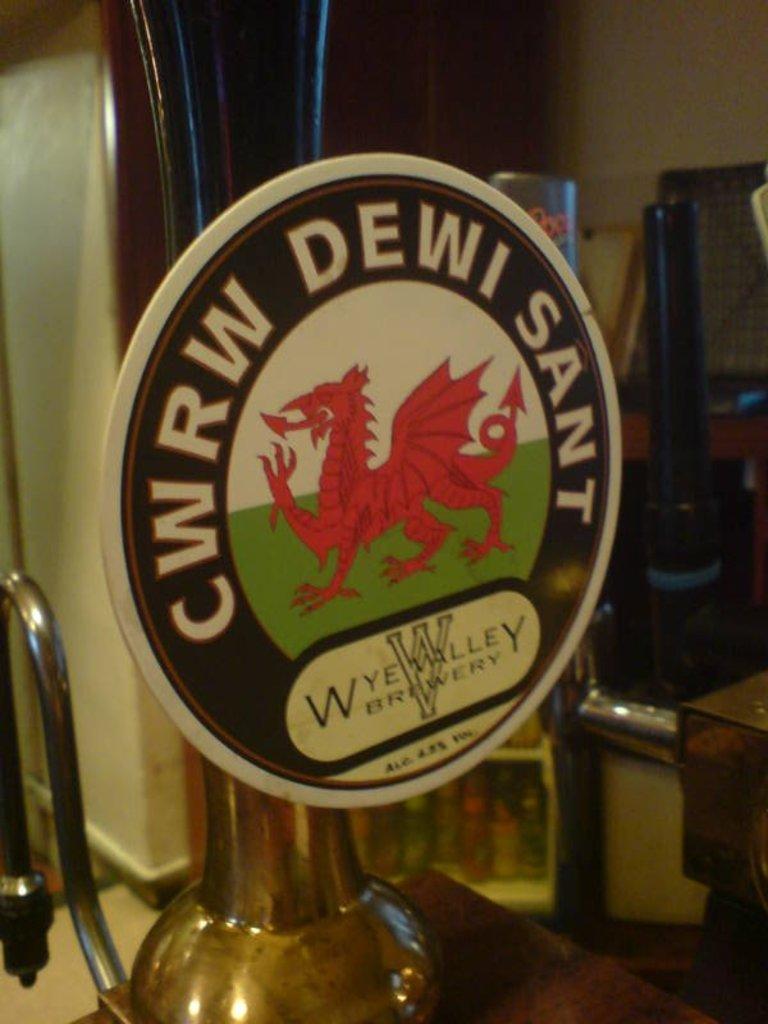What brand name is seen here?
Your response must be concise. Cwrw dewi sant. What is the name of the brewery?
Your response must be concise. Wye valley. 